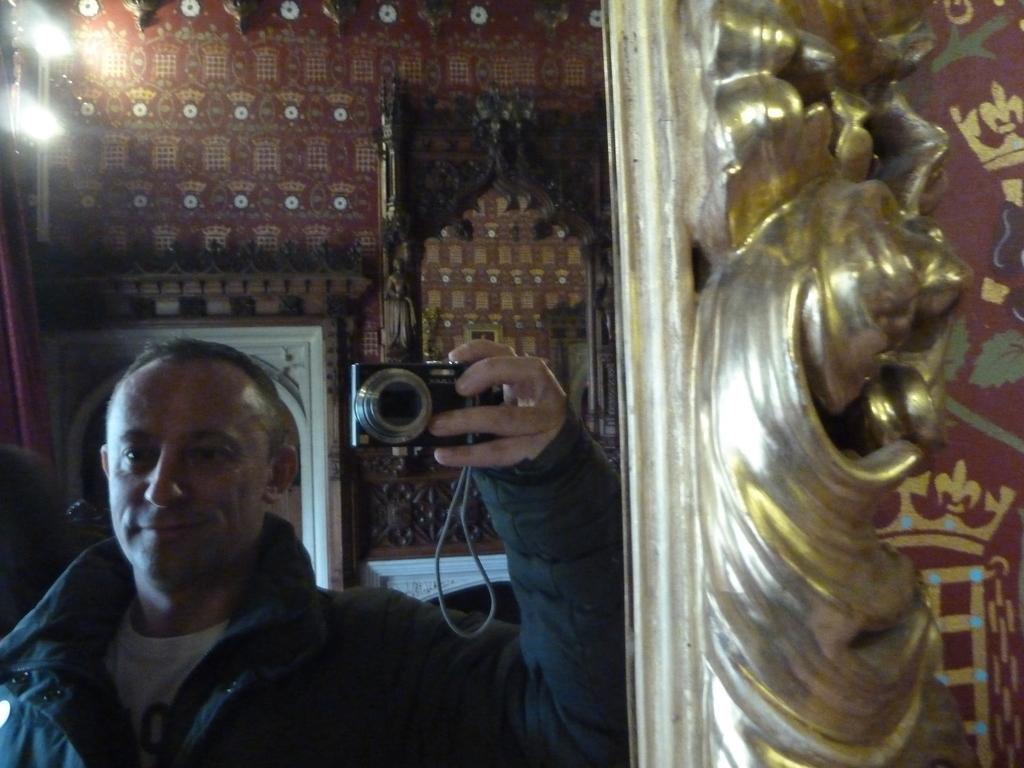Describe this image in one or two sentences. On the left side of the image we can see person holding camera through the mirror. In the background there is wall. 